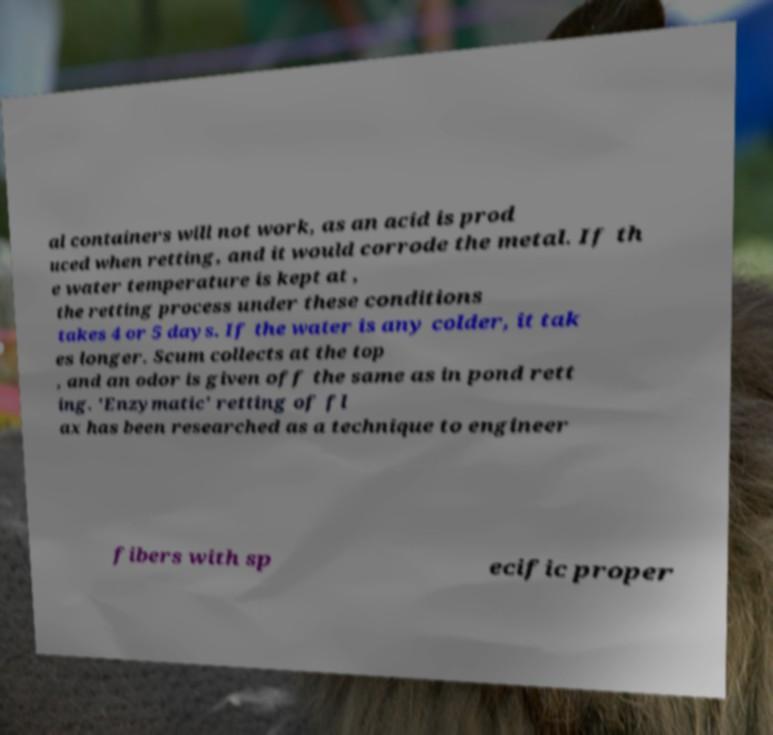I need the written content from this picture converted into text. Can you do that? al containers will not work, as an acid is prod uced when retting, and it would corrode the metal. If th e water temperature is kept at , the retting process under these conditions takes 4 or 5 days. If the water is any colder, it tak es longer. Scum collects at the top , and an odor is given off the same as in pond rett ing. 'Enzymatic' retting of fl ax has been researched as a technique to engineer fibers with sp ecific proper 